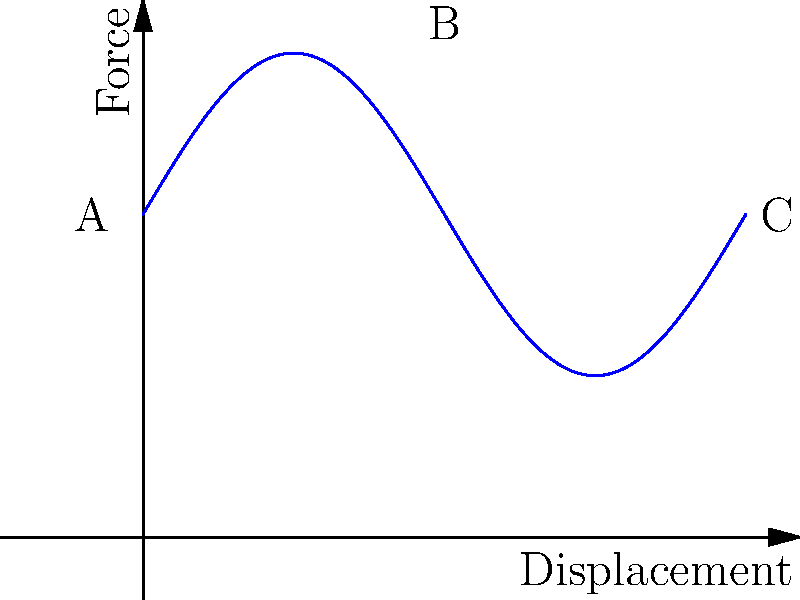As a marketing student working on a campaign for a local engineering firm, you come across a force-displacement curve for a spring-mass-damper system under harmonic excitation. The curve is shown above. Which point on the curve represents the maximum force applied to the system? To answer this question, we need to understand the basic principles of a force-displacement curve for a spring-mass-damper system under harmonic excitation:

1. The curve represents the relationship between the force applied to the system and the resulting displacement.

2. In a harmonic excitation, the force varies sinusoidally over time.

3. The force-displacement curve for such a system typically forms a loop, known as a hysteresis loop.

4. The maximum force applied to the system corresponds to the highest point on the curve.

Analyzing the given curve:

- Point A is at the start of the curve, representing a low force value.
- Point C is at the end of the curve, also representing a low force value.
- Point B is at the top of the curve, representing the highest force value.

Therefore, point B represents the maximum force applied to the system during the harmonic excitation.
Answer: Point B 